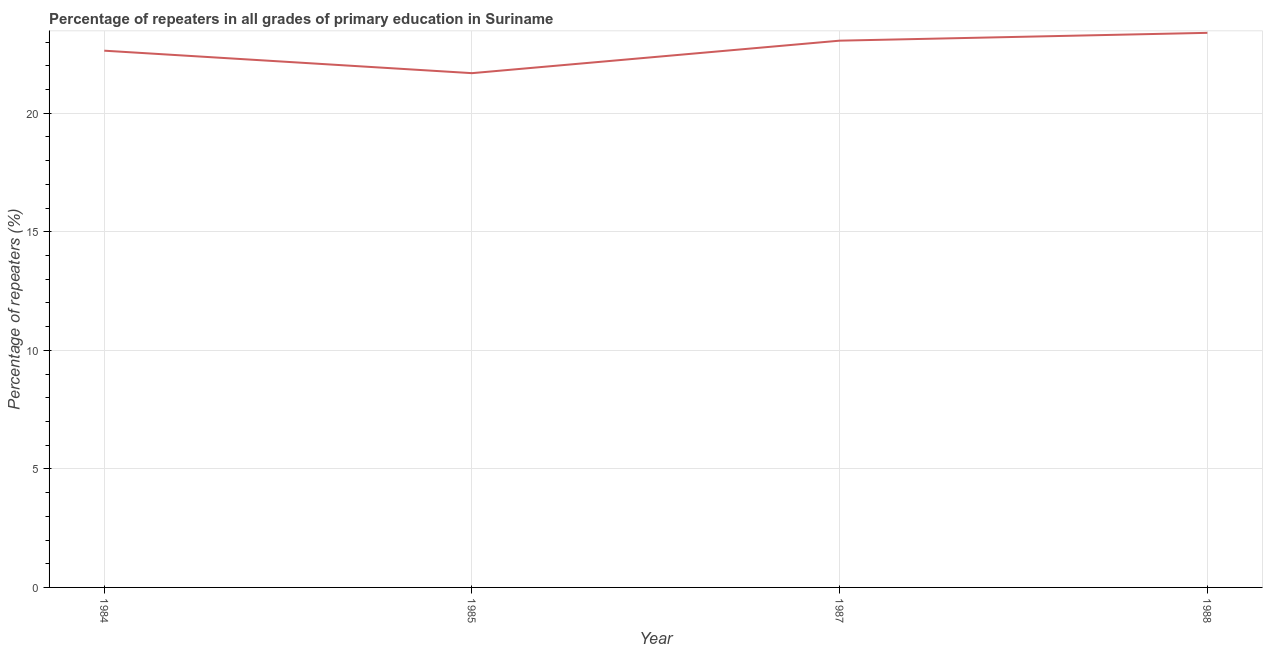What is the percentage of repeaters in primary education in 1985?
Your response must be concise. 21.69. Across all years, what is the maximum percentage of repeaters in primary education?
Your answer should be very brief. 23.39. Across all years, what is the minimum percentage of repeaters in primary education?
Offer a very short reply. 21.69. In which year was the percentage of repeaters in primary education maximum?
Provide a short and direct response. 1988. In which year was the percentage of repeaters in primary education minimum?
Give a very brief answer. 1985. What is the sum of the percentage of repeaters in primary education?
Your answer should be compact. 90.79. What is the difference between the percentage of repeaters in primary education in 1984 and 1985?
Provide a short and direct response. 0.95. What is the average percentage of repeaters in primary education per year?
Ensure brevity in your answer.  22.7. What is the median percentage of repeaters in primary education?
Your response must be concise. 22.85. What is the ratio of the percentage of repeaters in primary education in 1985 to that in 1987?
Your response must be concise. 0.94. Is the percentage of repeaters in primary education in 1984 less than that in 1987?
Your answer should be very brief. Yes. Is the difference between the percentage of repeaters in primary education in 1984 and 1988 greater than the difference between any two years?
Make the answer very short. No. What is the difference between the highest and the second highest percentage of repeaters in primary education?
Keep it short and to the point. 0.33. What is the difference between the highest and the lowest percentage of repeaters in primary education?
Keep it short and to the point. 1.7. Does the percentage of repeaters in primary education monotonically increase over the years?
Provide a short and direct response. No. How many lines are there?
Provide a succinct answer. 1. Are the values on the major ticks of Y-axis written in scientific E-notation?
Offer a terse response. No. Does the graph contain any zero values?
Give a very brief answer. No. Does the graph contain grids?
Give a very brief answer. Yes. What is the title of the graph?
Your answer should be compact. Percentage of repeaters in all grades of primary education in Suriname. What is the label or title of the X-axis?
Ensure brevity in your answer.  Year. What is the label or title of the Y-axis?
Provide a short and direct response. Percentage of repeaters (%). What is the Percentage of repeaters (%) in 1984?
Provide a short and direct response. 22.64. What is the Percentage of repeaters (%) in 1985?
Ensure brevity in your answer.  21.69. What is the Percentage of repeaters (%) of 1987?
Your response must be concise. 23.06. What is the Percentage of repeaters (%) in 1988?
Give a very brief answer. 23.39. What is the difference between the Percentage of repeaters (%) in 1984 and 1985?
Keep it short and to the point. 0.95. What is the difference between the Percentage of repeaters (%) in 1984 and 1987?
Offer a terse response. -0.42. What is the difference between the Percentage of repeaters (%) in 1984 and 1988?
Give a very brief answer. -0.75. What is the difference between the Percentage of repeaters (%) in 1985 and 1987?
Your response must be concise. -1.37. What is the difference between the Percentage of repeaters (%) in 1985 and 1988?
Your response must be concise. -1.7. What is the difference between the Percentage of repeaters (%) in 1987 and 1988?
Your response must be concise. -0.33. What is the ratio of the Percentage of repeaters (%) in 1984 to that in 1985?
Your answer should be very brief. 1.04. What is the ratio of the Percentage of repeaters (%) in 1984 to that in 1988?
Make the answer very short. 0.97. What is the ratio of the Percentage of repeaters (%) in 1985 to that in 1987?
Provide a succinct answer. 0.94. What is the ratio of the Percentage of repeaters (%) in 1985 to that in 1988?
Offer a terse response. 0.93. 